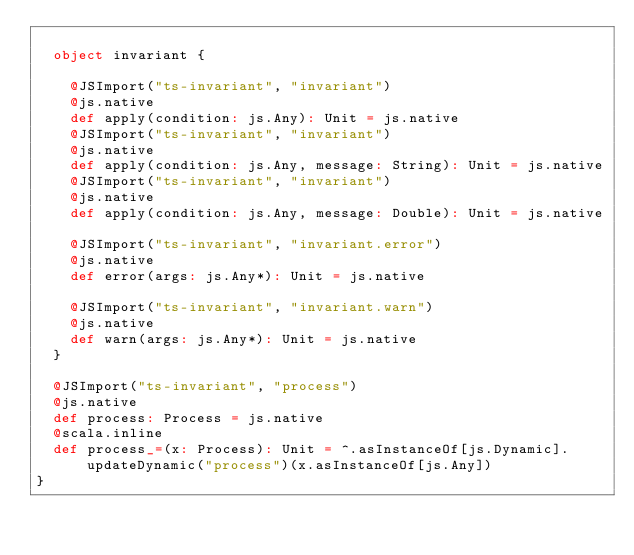<code> <loc_0><loc_0><loc_500><loc_500><_Scala_>  
  object invariant {
    
    @JSImport("ts-invariant", "invariant")
    @js.native
    def apply(condition: js.Any): Unit = js.native
    @JSImport("ts-invariant", "invariant")
    @js.native
    def apply(condition: js.Any, message: String): Unit = js.native
    @JSImport("ts-invariant", "invariant")
    @js.native
    def apply(condition: js.Any, message: Double): Unit = js.native
    
    @JSImport("ts-invariant", "invariant.error")
    @js.native
    def error(args: js.Any*): Unit = js.native
    
    @JSImport("ts-invariant", "invariant.warn")
    @js.native
    def warn(args: js.Any*): Unit = js.native
  }
  
  @JSImport("ts-invariant", "process")
  @js.native
  def process: Process = js.native
  @scala.inline
  def process_=(x: Process): Unit = ^.asInstanceOf[js.Dynamic].updateDynamic("process")(x.asInstanceOf[js.Any])
}
</code> 